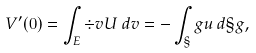Convert formula to latex. <formula><loc_0><loc_0><loc_500><loc_500>V ^ { \prime } ( 0 ) = \int _ { E } \div v U \, d v = - \int _ { \S } g u \, d \S g ,</formula> 